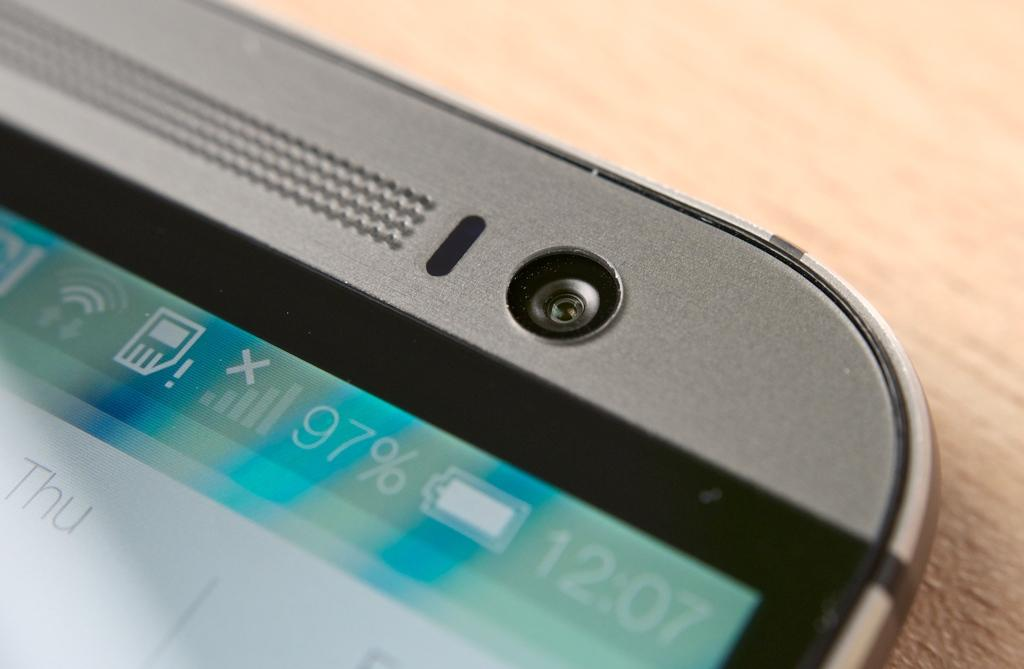<image>
Summarize the visual content of the image. The top of a cell phone showing a 97% chage and the time of 12:07. 